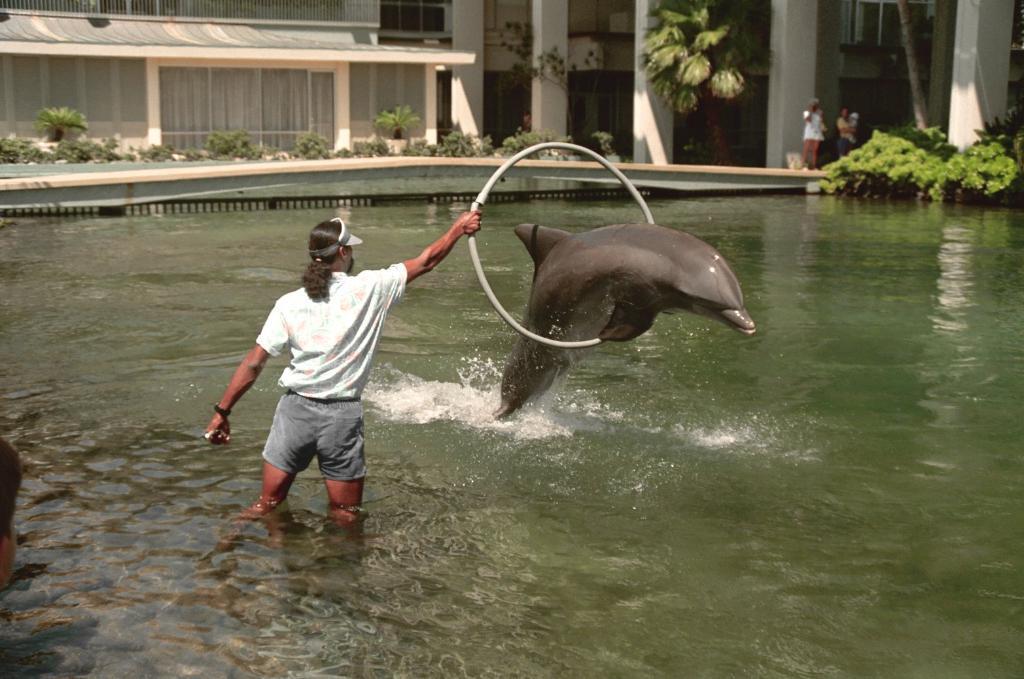Can you describe this image briefly? In this image we can see a man standing in a water body holding a ring. We can also see a dolphin, some people standing on the ground, a tree, some plants and a building with windows and pillars. 